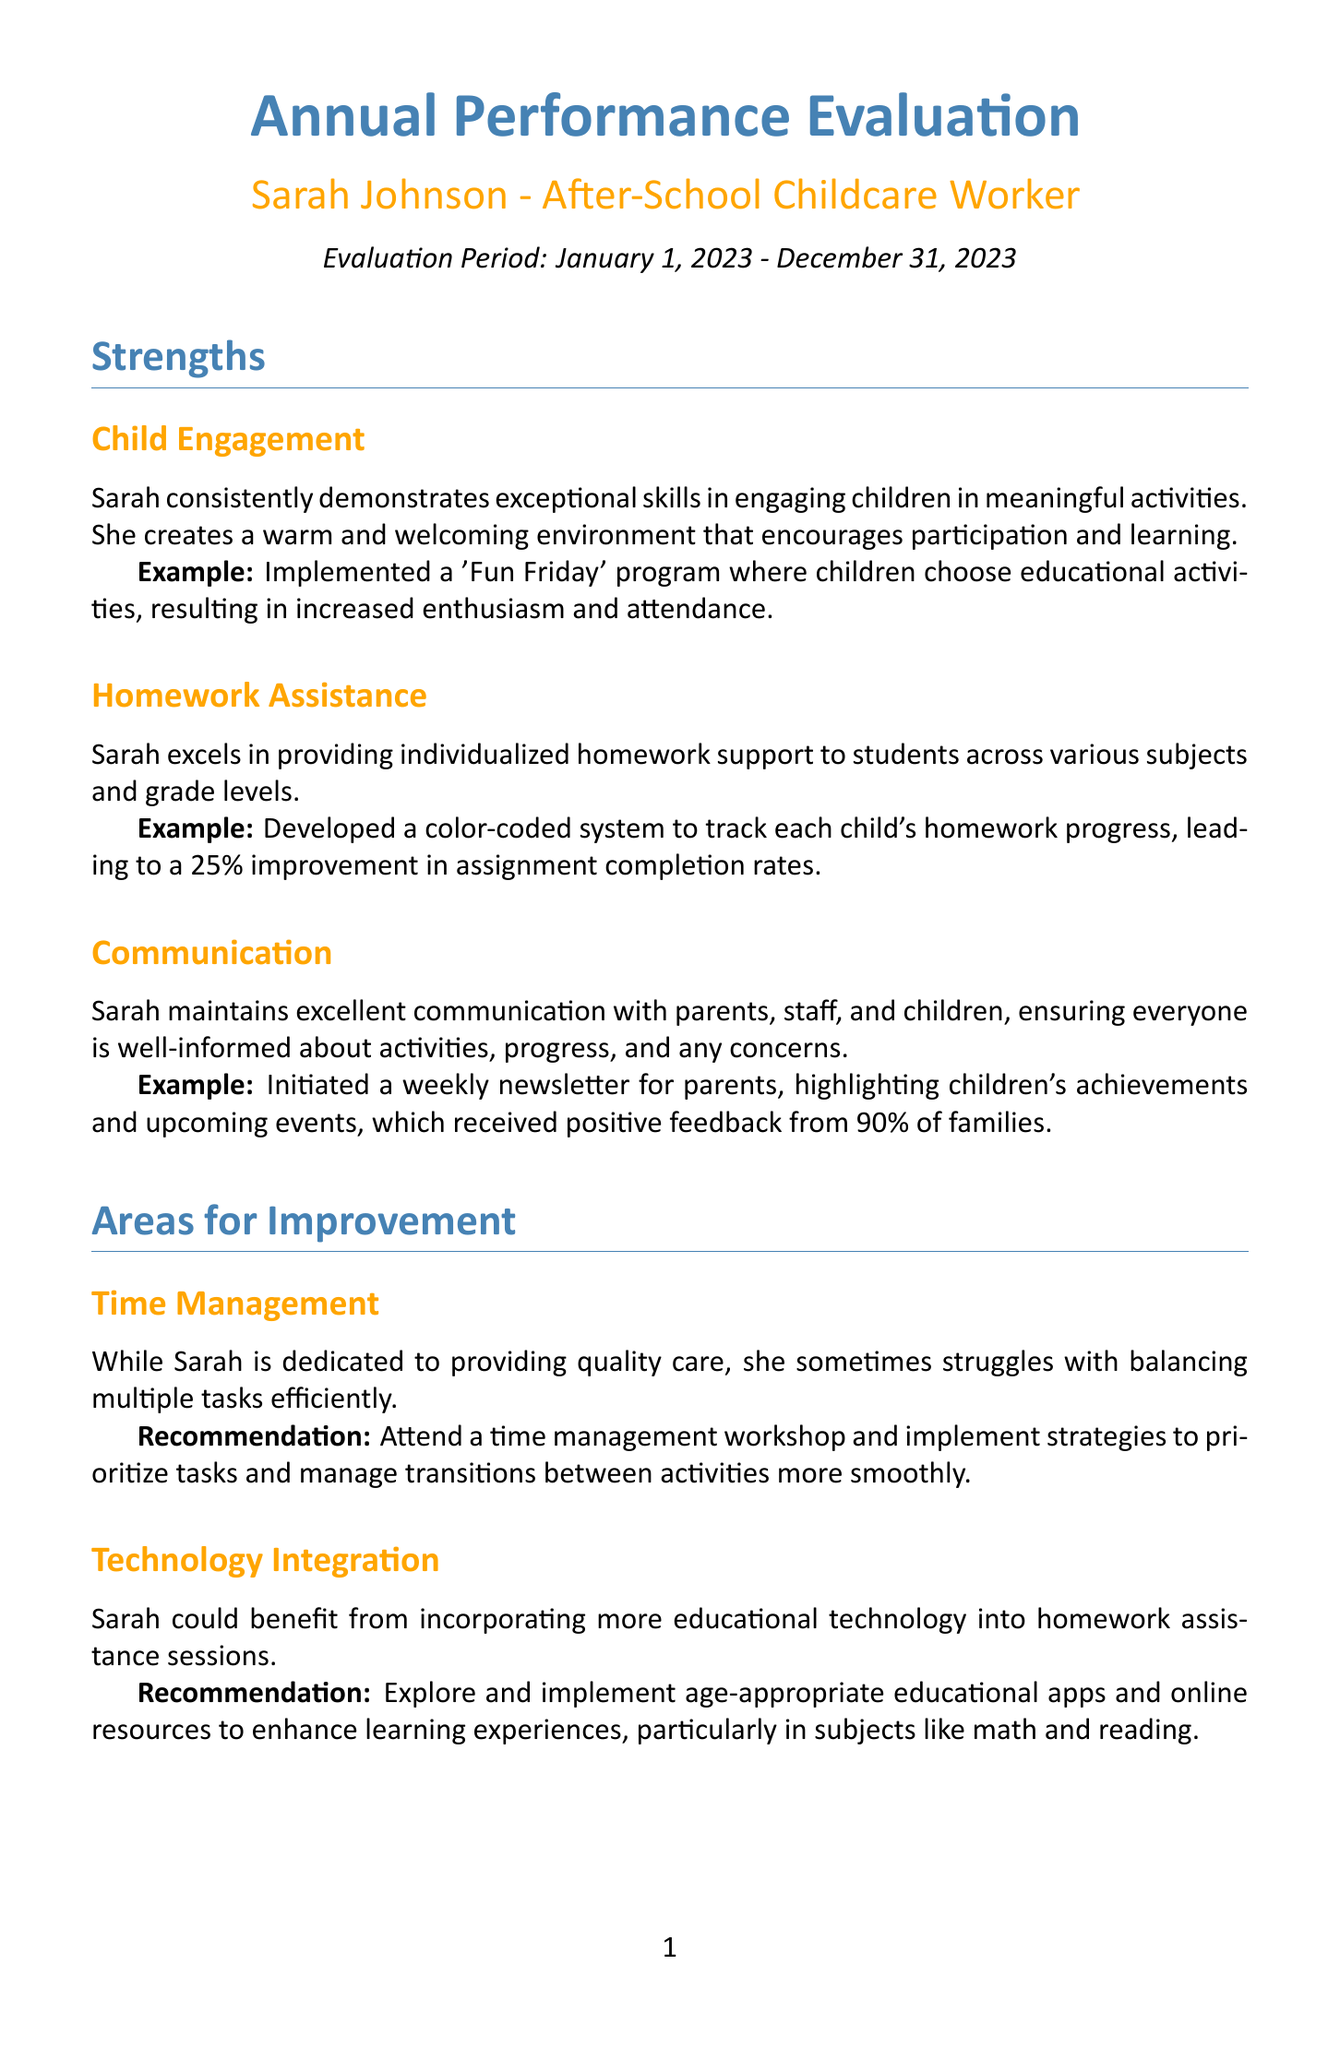What is the employee's name? The employee's name is listed at the beginning of the document under the title section.
Answer: Sarah Johnson What is the evaluation period? The evaluation period is specified in the introduction of the document.
Answer: January 1, 2023 - December 31, 2023 What is Sarah's score for parent satisfaction? The parent satisfaction score is presented in the performance metrics section of the document.
Answer: 4.7 What area did Sarah excel in that led to improved homework completion rates? The strengths section highlights her effective strategies related to homework assistance that contributed to better outcomes.
Answer: Homework Assistance What is one of Sarah's goals for next year? The goals for next year are explicitly listed in the goals section of the document.
Answer: Implement a structured reading program What recommendation is made for improving Sarah's time management? The recommendation for time management is provided in the areas for improvement section to guide her future development.
Answer: Attend a time management workshop What was the overall rating of Sarah's performance? The overall rating is mentioned in the conclusion of the document summarizing her performance metrics.
Answer: Exceeds Expectations How many courses related to professional development did Sarah complete? The professional development section lists the courses completed alongside their respective completion dates.
Answer: 2 